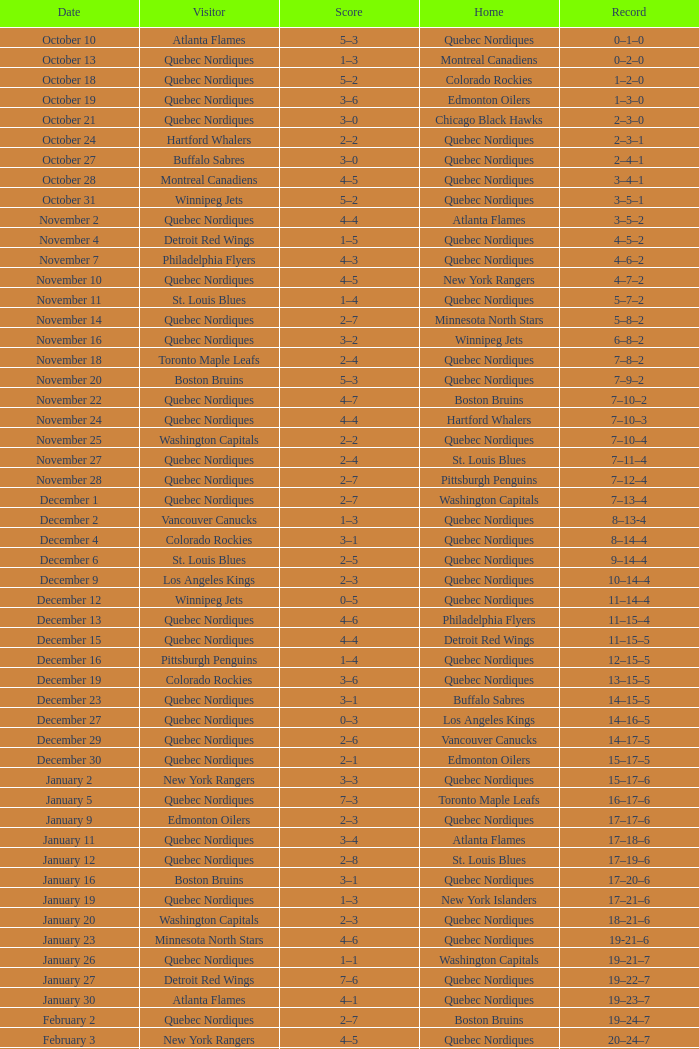Which record is associated with the edmonton oilers' home and has a score of 3-6? 1–3–0. 